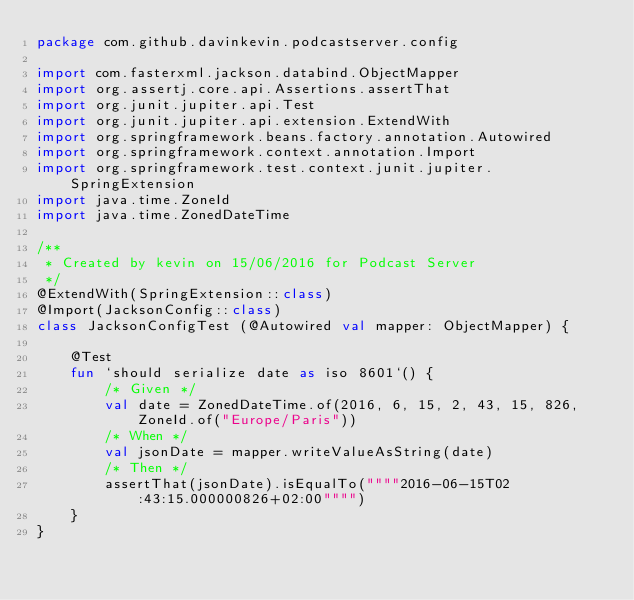<code> <loc_0><loc_0><loc_500><loc_500><_Kotlin_>package com.github.davinkevin.podcastserver.config

import com.fasterxml.jackson.databind.ObjectMapper
import org.assertj.core.api.Assertions.assertThat
import org.junit.jupiter.api.Test
import org.junit.jupiter.api.extension.ExtendWith
import org.springframework.beans.factory.annotation.Autowired
import org.springframework.context.annotation.Import
import org.springframework.test.context.junit.jupiter.SpringExtension
import java.time.ZoneId
import java.time.ZonedDateTime

/**
 * Created by kevin on 15/06/2016 for Podcast Server
 */
@ExtendWith(SpringExtension::class)
@Import(JacksonConfig::class)
class JacksonConfigTest (@Autowired val mapper: ObjectMapper) {

    @Test
    fun `should serialize date as iso 8601`() {
        /* Given */
        val date = ZonedDateTime.of(2016, 6, 15, 2, 43, 15, 826, ZoneId.of("Europe/Paris"))
        /* When */
        val jsonDate = mapper.writeValueAsString(date)
        /* Then */
        assertThat(jsonDate).isEqualTo(""""2016-06-15T02:43:15.000000826+02:00"""")
    }
}
</code> 